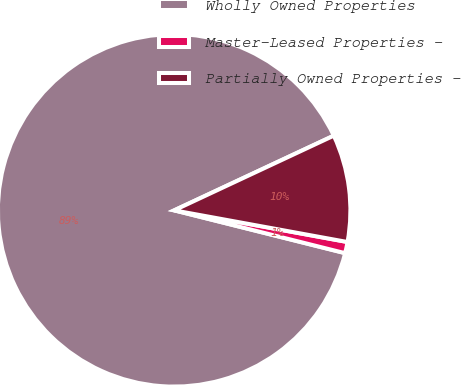Convert chart to OTSL. <chart><loc_0><loc_0><loc_500><loc_500><pie_chart><fcel>Wholly Owned Properties<fcel>Master-Leased Properties -<fcel>Partially Owned Properties -<nl><fcel>89.12%<fcel>1.03%<fcel>9.84%<nl></chart> 